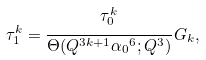Convert formula to latex. <formula><loc_0><loc_0><loc_500><loc_500>\tau ^ { k } _ { 1 } = \cfrac { \tau _ { 0 } ^ { k } } { \Theta ( Q ^ { 3 k + 1 } { \alpha _ { 0 } } ^ { 6 } ; Q ^ { 3 } ) } \, G _ { k } ,</formula> 